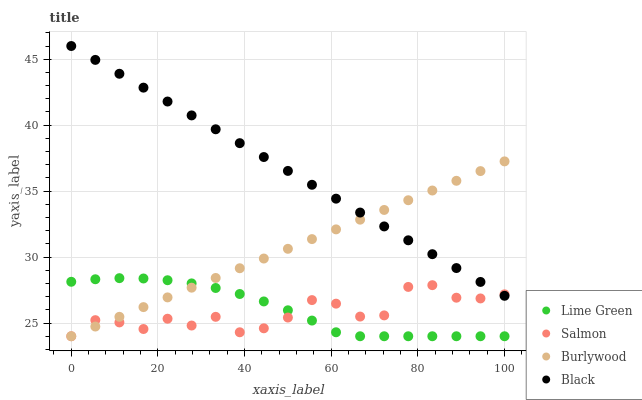Does Salmon have the minimum area under the curve?
Answer yes or no. Yes. Does Black have the maximum area under the curve?
Answer yes or no. Yes. Does Lime Green have the minimum area under the curve?
Answer yes or no. No. Does Lime Green have the maximum area under the curve?
Answer yes or no. No. Is Burlywood the smoothest?
Answer yes or no. Yes. Is Salmon the roughest?
Answer yes or no. Yes. Is Lime Green the smoothest?
Answer yes or no. No. Is Lime Green the roughest?
Answer yes or no. No. Does Burlywood have the lowest value?
Answer yes or no. Yes. Does Black have the lowest value?
Answer yes or no. No. Does Black have the highest value?
Answer yes or no. Yes. Does Lime Green have the highest value?
Answer yes or no. No. Is Lime Green less than Black?
Answer yes or no. Yes. Is Black greater than Lime Green?
Answer yes or no. Yes. Does Salmon intersect Black?
Answer yes or no. Yes. Is Salmon less than Black?
Answer yes or no. No. Is Salmon greater than Black?
Answer yes or no. No. Does Lime Green intersect Black?
Answer yes or no. No. 